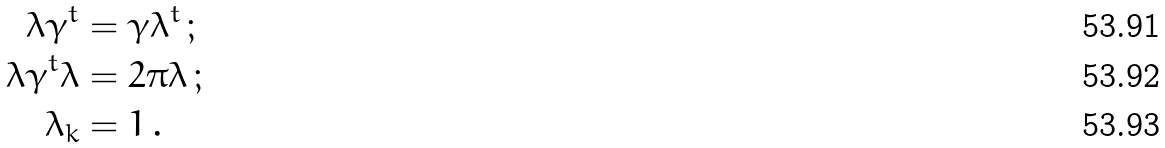<formula> <loc_0><loc_0><loc_500><loc_500>\lambda \gamma ^ { t } & = \gamma \lambda ^ { t } \, ; \\ \lambda \gamma ^ { t } \lambda & = 2 \pi \lambda \, ; \\ \lambda _ { k } & = 1 \, .</formula> 